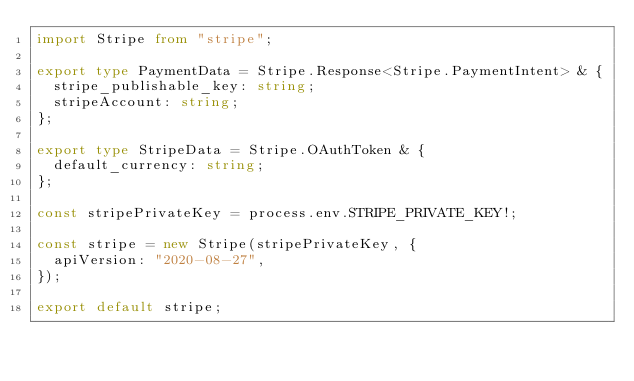<code> <loc_0><loc_0><loc_500><loc_500><_TypeScript_>import Stripe from "stripe";

export type PaymentData = Stripe.Response<Stripe.PaymentIntent> & {
  stripe_publishable_key: string;
  stripeAccount: string;
};

export type StripeData = Stripe.OAuthToken & {
  default_currency: string;
};

const stripePrivateKey = process.env.STRIPE_PRIVATE_KEY!;

const stripe = new Stripe(stripePrivateKey, {
  apiVersion: "2020-08-27",
});

export default stripe;
</code> 